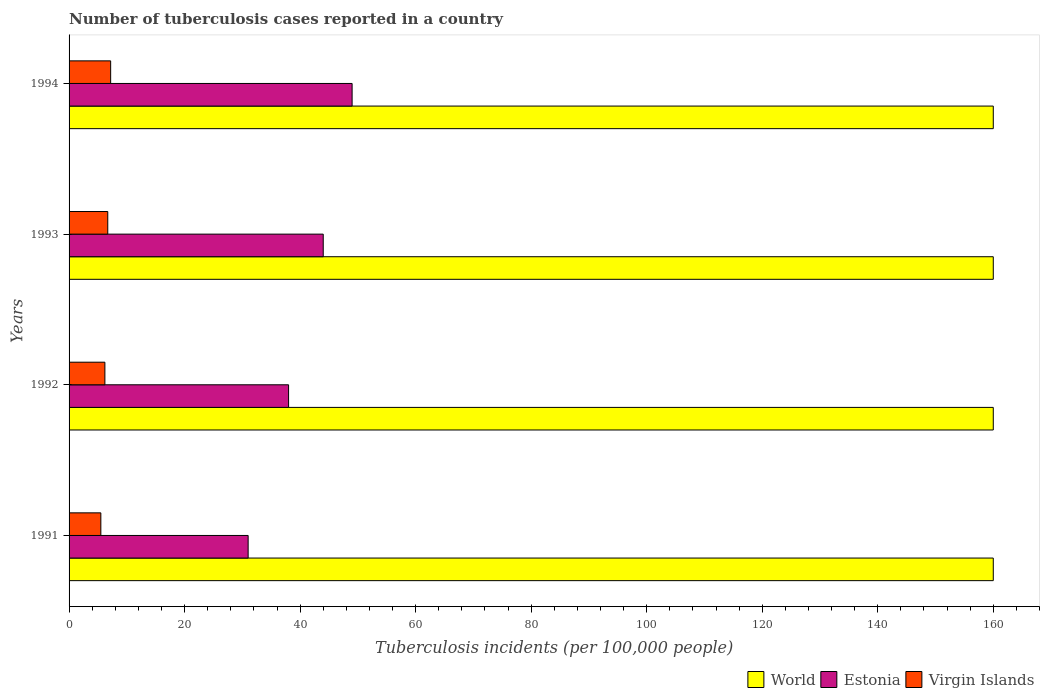How many different coloured bars are there?
Your answer should be compact. 3. Are the number of bars on each tick of the Y-axis equal?
Make the answer very short. Yes. What is the label of the 3rd group of bars from the top?
Provide a succinct answer. 1992. In how many cases, is the number of bars for a given year not equal to the number of legend labels?
Offer a very short reply. 0. What is the number of tuberculosis cases reported in in Estonia in 1992?
Offer a terse response. 38. Across all years, what is the minimum number of tuberculosis cases reported in in Estonia?
Offer a terse response. 31. In which year was the number of tuberculosis cases reported in in Estonia minimum?
Your response must be concise. 1991. What is the total number of tuberculosis cases reported in in Estonia in the graph?
Keep it short and to the point. 162. What is the difference between the number of tuberculosis cases reported in in World in 1992 and that in 1993?
Your answer should be very brief. 0. What is the difference between the number of tuberculosis cases reported in in Virgin Islands in 1992 and the number of tuberculosis cases reported in in World in 1993?
Your response must be concise. -153.8. What is the average number of tuberculosis cases reported in in World per year?
Your answer should be very brief. 160. In the year 1994, what is the difference between the number of tuberculosis cases reported in in Virgin Islands and number of tuberculosis cases reported in in Estonia?
Make the answer very short. -41.8. In how many years, is the number of tuberculosis cases reported in in Virgin Islands greater than 164 ?
Your answer should be compact. 0. What is the ratio of the number of tuberculosis cases reported in in Estonia in 1992 to that in 1994?
Offer a terse response. 0.78. Is the number of tuberculosis cases reported in in Virgin Islands in 1992 less than that in 1993?
Provide a short and direct response. Yes. What is the difference between the highest and the second highest number of tuberculosis cases reported in in Virgin Islands?
Keep it short and to the point. 0.5. What is the difference between the highest and the lowest number of tuberculosis cases reported in in World?
Offer a very short reply. 0. What does the 1st bar from the top in 1993 represents?
Your answer should be compact. Virgin Islands. What does the 2nd bar from the bottom in 1994 represents?
Your answer should be compact. Estonia. How many years are there in the graph?
Offer a very short reply. 4. What is the difference between two consecutive major ticks on the X-axis?
Make the answer very short. 20. Does the graph contain any zero values?
Provide a short and direct response. No. Does the graph contain grids?
Your answer should be compact. No. How many legend labels are there?
Provide a short and direct response. 3. What is the title of the graph?
Your answer should be very brief. Number of tuberculosis cases reported in a country. Does "Qatar" appear as one of the legend labels in the graph?
Your answer should be very brief. No. What is the label or title of the X-axis?
Ensure brevity in your answer.  Tuberculosis incidents (per 100,0 people). What is the label or title of the Y-axis?
Offer a terse response. Years. What is the Tuberculosis incidents (per 100,000 people) of World in 1991?
Ensure brevity in your answer.  160. What is the Tuberculosis incidents (per 100,000 people) in Virgin Islands in 1991?
Keep it short and to the point. 5.5. What is the Tuberculosis incidents (per 100,000 people) in World in 1992?
Make the answer very short. 160. What is the Tuberculosis incidents (per 100,000 people) in Estonia in 1992?
Give a very brief answer. 38. What is the Tuberculosis incidents (per 100,000 people) of World in 1993?
Give a very brief answer. 160. What is the Tuberculosis incidents (per 100,000 people) of Estonia in 1993?
Your answer should be very brief. 44. What is the Tuberculosis incidents (per 100,000 people) in World in 1994?
Make the answer very short. 160. What is the Tuberculosis incidents (per 100,000 people) in Virgin Islands in 1994?
Ensure brevity in your answer.  7.2. Across all years, what is the maximum Tuberculosis incidents (per 100,000 people) in World?
Offer a very short reply. 160. Across all years, what is the maximum Tuberculosis incidents (per 100,000 people) in Virgin Islands?
Your response must be concise. 7.2. Across all years, what is the minimum Tuberculosis incidents (per 100,000 people) of World?
Offer a terse response. 160. What is the total Tuberculosis incidents (per 100,000 people) in World in the graph?
Ensure brevity in your answer.  640. What is the total Tuberculosis incidents (per 100,000 people) of Estonia in the graph?
Provide a succinct answer. 162. What is the total Tuberculosis incidents (per 100,000 people) in Virgin Islands in the graph?
Give a very brief answer. 25.6. What is the difference between the Tuberculosis incidents (per 100,000 people) in Estonia in 1991 and that in 1992?
Offer a terse response. -7. What is the difference between the Tuberculosis incidents (per 100,000 people) in Estonia in 1991 and that in 1993?
Ensure brevity in your answer.  -13. What is the difference between the Tuberculosis incidents (per 100,000 people) in Virgin Islands in 1991 and that in 1993?
Keep it short and to the point. -1.2. What is the difference between the Tuberculosis incidents (per 100,000 people) of World in 1991 and that in 1994?
Offer a very short reply. 0. What is the difference between the Tuberculosis incidents (per 100,000 people) in World in 1992 and that in 1993?
Give a very brief answer. 0. What is the difference between the Tuberculosis incidents (per 100,000 people) of Virgin Islands in 1992 and that in 1993?
Keep it short and to the point. -0.5. What is the difference between the Tuberculosis incidents (per 100,000 people) of Estonia in 1992 and that in 1994?
Offer a terse response. -11. What is the difference between the Tuberculosis incidents (per 100,000 people) in Virgin Islands in 1992 and that in 1994?
Ensure brevity in your answer.  -1. What is the difference between the Tuberculosis incidents (per 100,000 people) of Estonia in 1993 and that in 1994?
Provide a succinct answer. -5. What is the difference between the Tuberculosis incidents (per 100,000 people) in World in 1991 and the Tuberculosis incidents (per 100,000 people) in Estonia in 1992?
Provide a short and direct response. 122. What is the difference between the Tuberculosis incidents (per 100,000 people) in World in 1991 and the Tuberculosis incidents (per 100,000 people) in Virgin Islands in 1992?
Keep it short and to the point. 153.8. What is the difference between the Tuberculosis incidents (per 100,000 people) in Estonia in 1991 and the Tuberculosis incidents (per 100,000 people) in Virgin Islands in 1992?
Provide a short and direct response. 24.8. What is the difference between the Tuberculosis incidents (per 100,000 people) in World in 1991 and the Tuberculosis incidents (per 100,000 people) in Estonia in 1993?
Your response must be concise. 116. What is the difference between the Tuberculosis incidents (per 100,000 people) of World in 1991 and the Tuberculosis incidents (per 100,000 people) of Virgin Islands in 1993?
Give a very brief answer. 153.3. What is the difference between the Tuberculosis incidents (per 100,000 people) in Estonia in 1991 and the Tuberculosis incidents (per 100,000 people) in Virgin Islands in 1993?
Your answer should be very brief. 24.3. What is the difference between the Tuberculosis incidents (per 100,000 people) in World in 1991 and the Tuberculosis incidents (per 100,000 people) in Estonia in 1994?
Provide a short and direct response. 111. What is the difference between the Tuberculosis incidents (per 100,000 people) of World in 1991 and the Tuberculosis incidents (per 100,000 people) of Virgin Islands in 1994?
Your answer should be compact. 152.8. What is the difference between the Tuberculosis incidents (per 100,000 people) of Estonia in 1991 and the Tuberculosis incidents (per 100,000 people) of Virgin Islands in 1994?
Provide a succinct answer. 23.8. What is the difference between the Tuberculosis incidents (per 100,000 people) of World in 1992 and the Tuberculosis incidents (per 100,000 people) of Estonia in 1993?
Your answer should be compact. 116. What is the difference between the Tuberculosis incidents (per 100,000 people) in World in 1992 and the Tuberculosis incidents (per 100,000 people) in Virgin Islands in 1993?
Your response must be concise. 153.3. What is the difference between the Tuberculosis incidents (per 100,000 people) of Estonia in 1992 and the Tuberculosis incidents (per 100,000 people) of Virgin Islands in 1993?
Your answer should be very brief. 31.3. What is the difference between the Tuberculosis incidents (per 100,000 people) in World in 1992 and the Tuberculosis incidents (per 100,000 people) in Estonia in 1994?
Your answer should be very brief. 111. What is the difference between the Tuberculosis incidents (per 100,000 people) in World in 1992 and the Tuberculosis incidents (per 100,000 people) in Virgin Islands in 1994?
Keep it short and to the point. 152.8. What is the difference between the Tuberculosis incidents (per 100,000 people) in Estonia in 1992 and the Tuberculosis incidents (per 100,000 people) in Virgin Islands in 1994?
Your answer should be compact. 30.8. What is the difference between the Tuberculosis incidents (per 100,000 people) of World in 1993 and the Tuberculosis incidents (per 100,000 people) of Estonia in 1994?
Make the answer very short. 111. What is the difference between the Tuberculosis incidents (per 100,000 people) in World in 1993 and the Tuberculosis incidents (per 100,000 people) in Virgin Islands in 1994?
Your answer should be compact. 152.8. What is the difference between the Tuberculosis incidents (per 100,000 people) in Estonia in 1993 and the Tuberculosis incidents (per 100,000 people) in Virgin Islands in 1994?
Offer a very short reply. 36.8. What is the average Tuberculosis incidents (per 100,000 people) of World per year?
Provide a short and direct response. 160. What is the average Tuberculosis incidents (per 100,000 people) of Estonia per year?
Ensure brevity in your answer.  40.5. In the year 1991, what is the difference between the Tuberculosis incidents (per 100,000 people) in World and Tuberculosis incidents (per 100,000 people) in Estonia?
Offer a terse response. 129. In the year 1991, what is the difference between the Tuberculosis incidents (per 100,000 people) of World and Tuberculosis incidents (per 100,000 people) of Virgin Islands?
Give a very brief answer. 154.5. In the year 1991, what is the difference between the Tuberculosis incidents (per 100,000 people) in Estonia and Tuberculosis incidents (per 100,000 people) in Virgin Islands?
Provide a succinct answer. 25.5. In the year 1992, what is the difference between the Tuberculosis incidents (per 100,000 people) of World and Tuberculosis incidents (per 100,000 people) of Estonia?
Offer a very short reply. 122. In the year 1992, what is the difference between the Tuberculosis incidents (per 100,000 people) in World and Tuberculosis incidents (per 100,000 people) in Virgin Islands?
Your answer should be very brief. 153.8. In the year 1992, what is the difference between the Tuberculosis incidents (per 100,000 people) in Estonia and Tuberculosis incidents (per 100,000 people) in Virgin Islands?
Give a very brief answer. 31.8. In the year 1993, what is the difference between the Tuberculosis incidents (per 100,000 people) of World and Tuberculosis incidents (per 100,000 people) of Estonia?
Provide a short and direct response. 116. In the year 1993, what is the difference between the Tuberculosis incidents (per 100,000 people) in World and Tuberculosis incidents (per 100,000 people) in Virgin Islands?
Your response must be concise. 153.3. In the year 1993, what is the difference between the Tuberculosis incidents (per 100,000 people) in Estonia and Tuberculosis incidents (per 100,000 people) in Virgin Islands?
Provide a succinct answer. 37.3. In the year 1994, what is the difference between the Tuberculosis incidents (per 100,000 people) in World and Tuberculosis incidents (per 100,000 people) in Estonia?
Keep it short and to the point. 111. In the year 1994, what is the difference between the Tuberculosis incidents (per 100,000 people) in World and Tuberculosis incidents (per 100,000 people) in Virgin Islands?
Offer a terse response. 152.8. In the year 1994, what is the difference between the Tuberculosis incidents (per 100,000 people) in Estonia and Tuberculosis incidents (per 100,000 people) in Virgin Islands?
Give a very brief answer. 41.8. What is the ratio of the Tuberculosis incidents (per 100,000 people) of World in 1991 to that in 1992?
Your answer should be very brief. 1. What is the ratio of the Tuberculosis incidents (per 100,000 people) of Estonia in 1991 to that in 1992?
Provide a short and direct response. 0.82. What is the ratio of the Tuberculosis incidents (per 100,000 people) of Virgin Islands in 1991 to that in 1992?
Make the answer very short. 0.89. What is the ratio of the Tuberculosis incidents (per 100,000 people) of World in 1991 to that in 1993?
Offer a very short reply. 1. What is the ratio of the Tuberculosis incidents (per 100,000 people) of Estonia in 1991 to that in 1993?
Offer a terse response. 0.7. What is the ratio of the Tuberculosis incidents (per 100,000 people) in Virgin Islands in 1991 to that in 1993?
Your answer should be very brief. 0.82. What is the ratio of the Tuberculosis incidents (per 100,000 people) in Estonia in 1991 to that in 1994?
Your response must be concise. 0.63. What is the ratio of the Tuberculosis incidents (per 100,000 people) in Virgin Islands in 1991 to that in 1994?
Your response must be concise. 0.76. What is the ratio of the Tuberculosis incidents (per 100,000 people) in World in 1992 to that in 1993?
Your response must be concise. 1. What is the ratio of the Tuberculosis incidents (per 100,000 people) of Estonia in 1992 to that in 1993?
Make the answer very short. 0.86. What is the ratio of the Tuberculosis incidents (per 100,000 people) of Virgin Islands in 1992 to that in 1993?
Your response must be concise. 0.93. What is the ratio of the Tuberculosis incidents (per 100,000 people) of World in 1992 to that in 1994?
Your answer should be compact. 1. What is the ratio of the Tuberculosis incidents (per 100,000 people) in Estonia in 1992 to that in 1994?
Offer a very short reply. 0.78. What is the ratio of the Tuberculosis incidents (per 100,000 people) in Virgin Islands in 1992 to that in 1994?
Keep it short and to the point. 0.86. What is the ratio of the Tuberculosis incidents (per 100,000 people) of World in 1993 to that in 1994?
Provide a short and direct response. 1. What is the ratio of the Tuberculosis incidents (per 100,000 people) in Estonia in 1993 to that in 1994?
Give a very brief answer. 0.9. What is the ratio of the Tuberculosis incidents (per 100,000 people) of Virgin Islands in 1993 to that in 1994?
Your answer should be very brief. 0.93. What is the difference between the highest and the second highest Tuberculosis incidents (per 100,000 people) of Estonia?
Keep it short and to the point. 5. What is the difference between the highest and the lowest Tuberculosis incidents (per 100,000 people) in World?
Make the answer very short. 0. What is the difference between the highest and the lowest Tuberculosis incidents (per 100,000 people) in Estonia?
Your response must be concise. 18. What is the difference between the highest and the lowest Tuberculosis incidents (per 100,000 people) of Virgin Islands?
Provide a succinct answer. 1.7. 